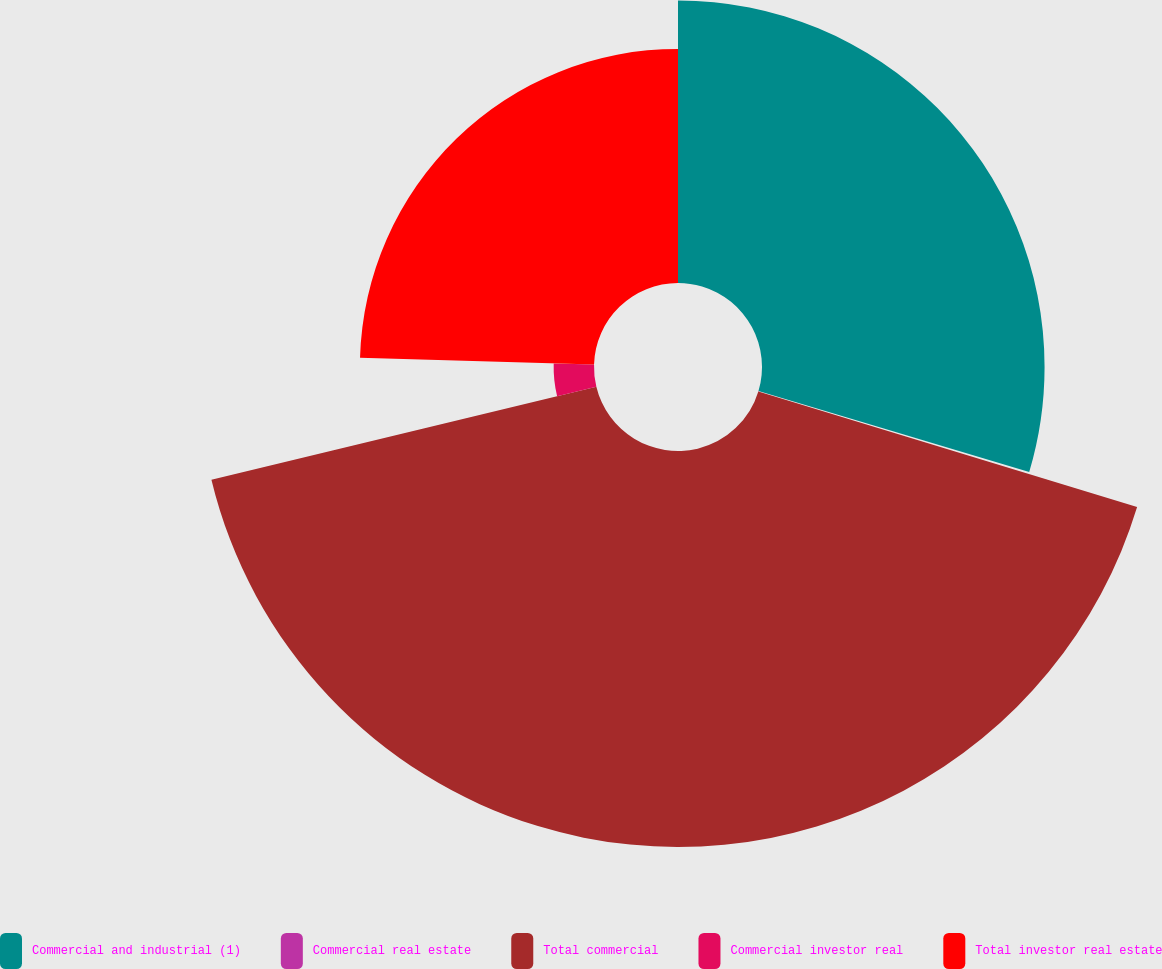<chart> <loc_0><loc_0><loc_500><loc_500><pie_chart><fcel>Commercial and industrial (1)<fcel>Commercial real estate<fcel>Total commercial<fcel>Commercial investor real<fcel>Total investor real estate<nl><fcel>29.62%<fcel>0.09%<fcel>41.51%<fcel>4.23%<fcel>24.54%<nl></chart> 